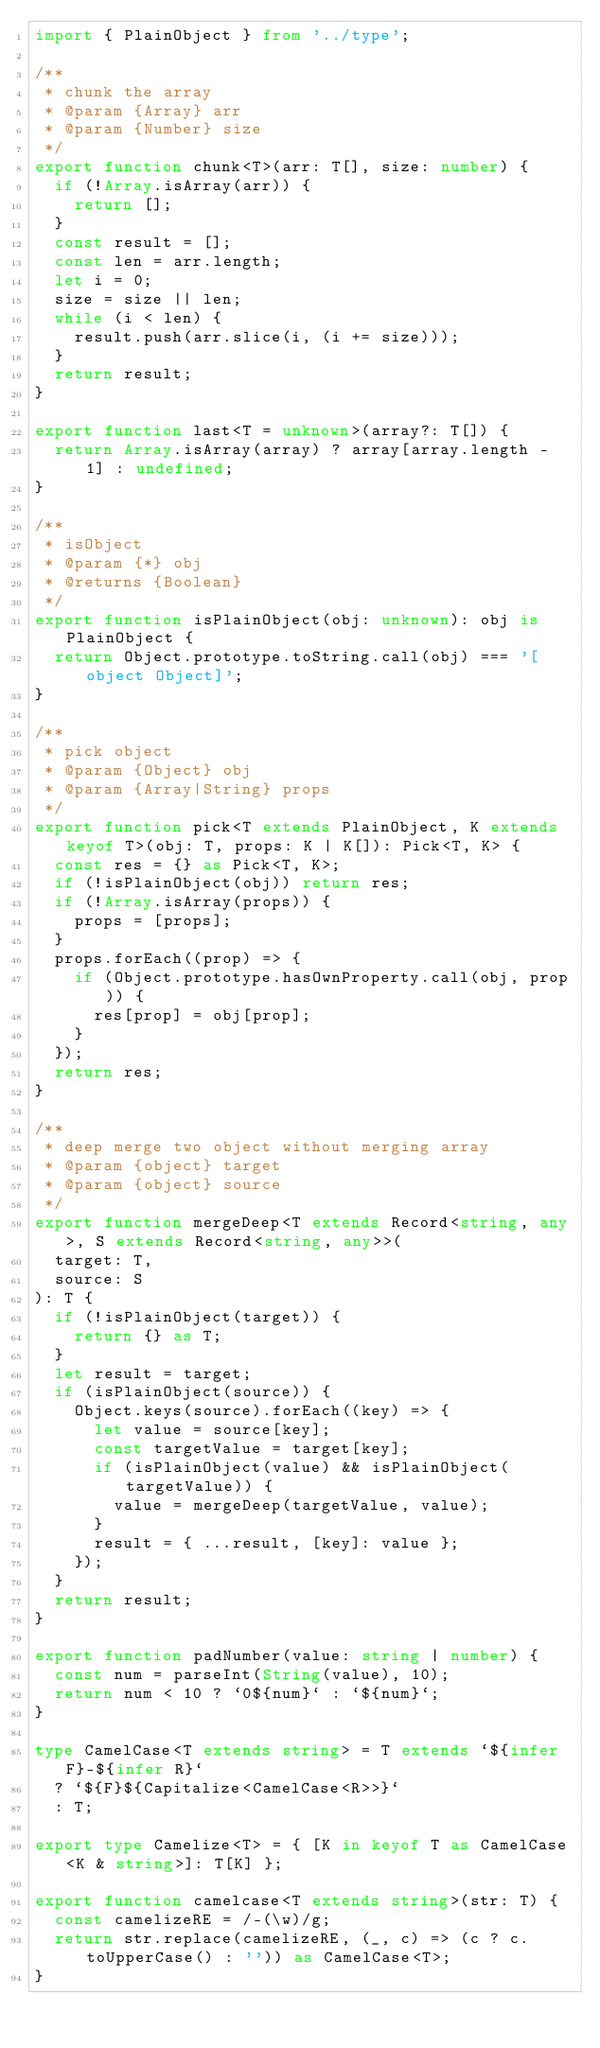<code> <loc_0><loc_0><loc_500><loc_500><_TypeScript_>import { PlainObject } from '../type';

/**
 * chunk the array
 * @param {Array} arr
 * @param {Number} size
 */
export function chunk<T>(arr: T[], size: number) {
  if (!Array.isArray(arr)) {
    return [];
  }
  const result = [];
  const len = arr.length;
  let i = 0;
  size = size || len;
  while (i < len) {
    result.push(arr.slice(i, (i += size)));
  }
  return result;
}

export function last<T = unknown>(array?: T[]) {
  return Array.isArray(array) ? array[array.length - 1] : undefined;
}

/**
 * isObject
 * @param {*} obj
 * @returns {Boolean}
 */
export function isPlainObject(obj: unknown): obj is PlainObject {
  return Object.prototype.toString.call(obj) === '[object Object]';
}

/**
 * pick object
 * @param {Object} obj
 * @param {Array|String} props
 */
export function pick<T extends PlainObject, K extends keyof T>(obj: T, props: K | K[]): Pick<T, K> {
  const res = {} as Pick<T, K>;
  if (!isPlainObject(obj)) return res;
  if (!Array.isArray(props)) {
    props = [props];
  }
  props.forEach((prop) => {
    if (Object.prototype.hasOwnProperty.call(obj, prop)) {
      res[prop] = obj[prop];
    }
  });
  return res;
}

/**
 * deep merge two object without merging array
 * @param {object} target
 * @param {object} source
 */
export function mergeDeep<T extends Record<string, any>, S extends Record<string, any>>(
  target: T,
  source: S
): T {
  if (!isPlainObject(target)) {
    return {} as T;
  }
  let result = target;
  if (isPlainObject(source)) {
    Object.keys(source).forEach((key) => {
      let value = source[key];
      const targetValue = target[key];
      if (isPlainObject(value) && isPlainObject(targetValue)) {
        value = mergeDeep(targetValue, value);
      }
      result = { ...result, [key]: value };
    });
  }
  return result;
}

export function padNumber(value: string | number) {
  const num = parseInt(String(value), 10);
  return num < 10 ? `0${num}` : `${num}`;
}

type CamelCase<T extends string> = T extends `${infer F}-${infer R}`
  ? `${F}${Capitalize<CamelCase<R>>}`
  : T;

export type Camelize<T> = { [K in keyof T as CamelCase<K & string>]: T[K] };

export function camelcase<T extends string>(str: T) {
  const camelizeRE = /-(\w)/g;
  return str.replace(camelizeRE, (_, c) => (c ? c.toUpperCase() : '')) as CamelCase<T>;
}
</code> 